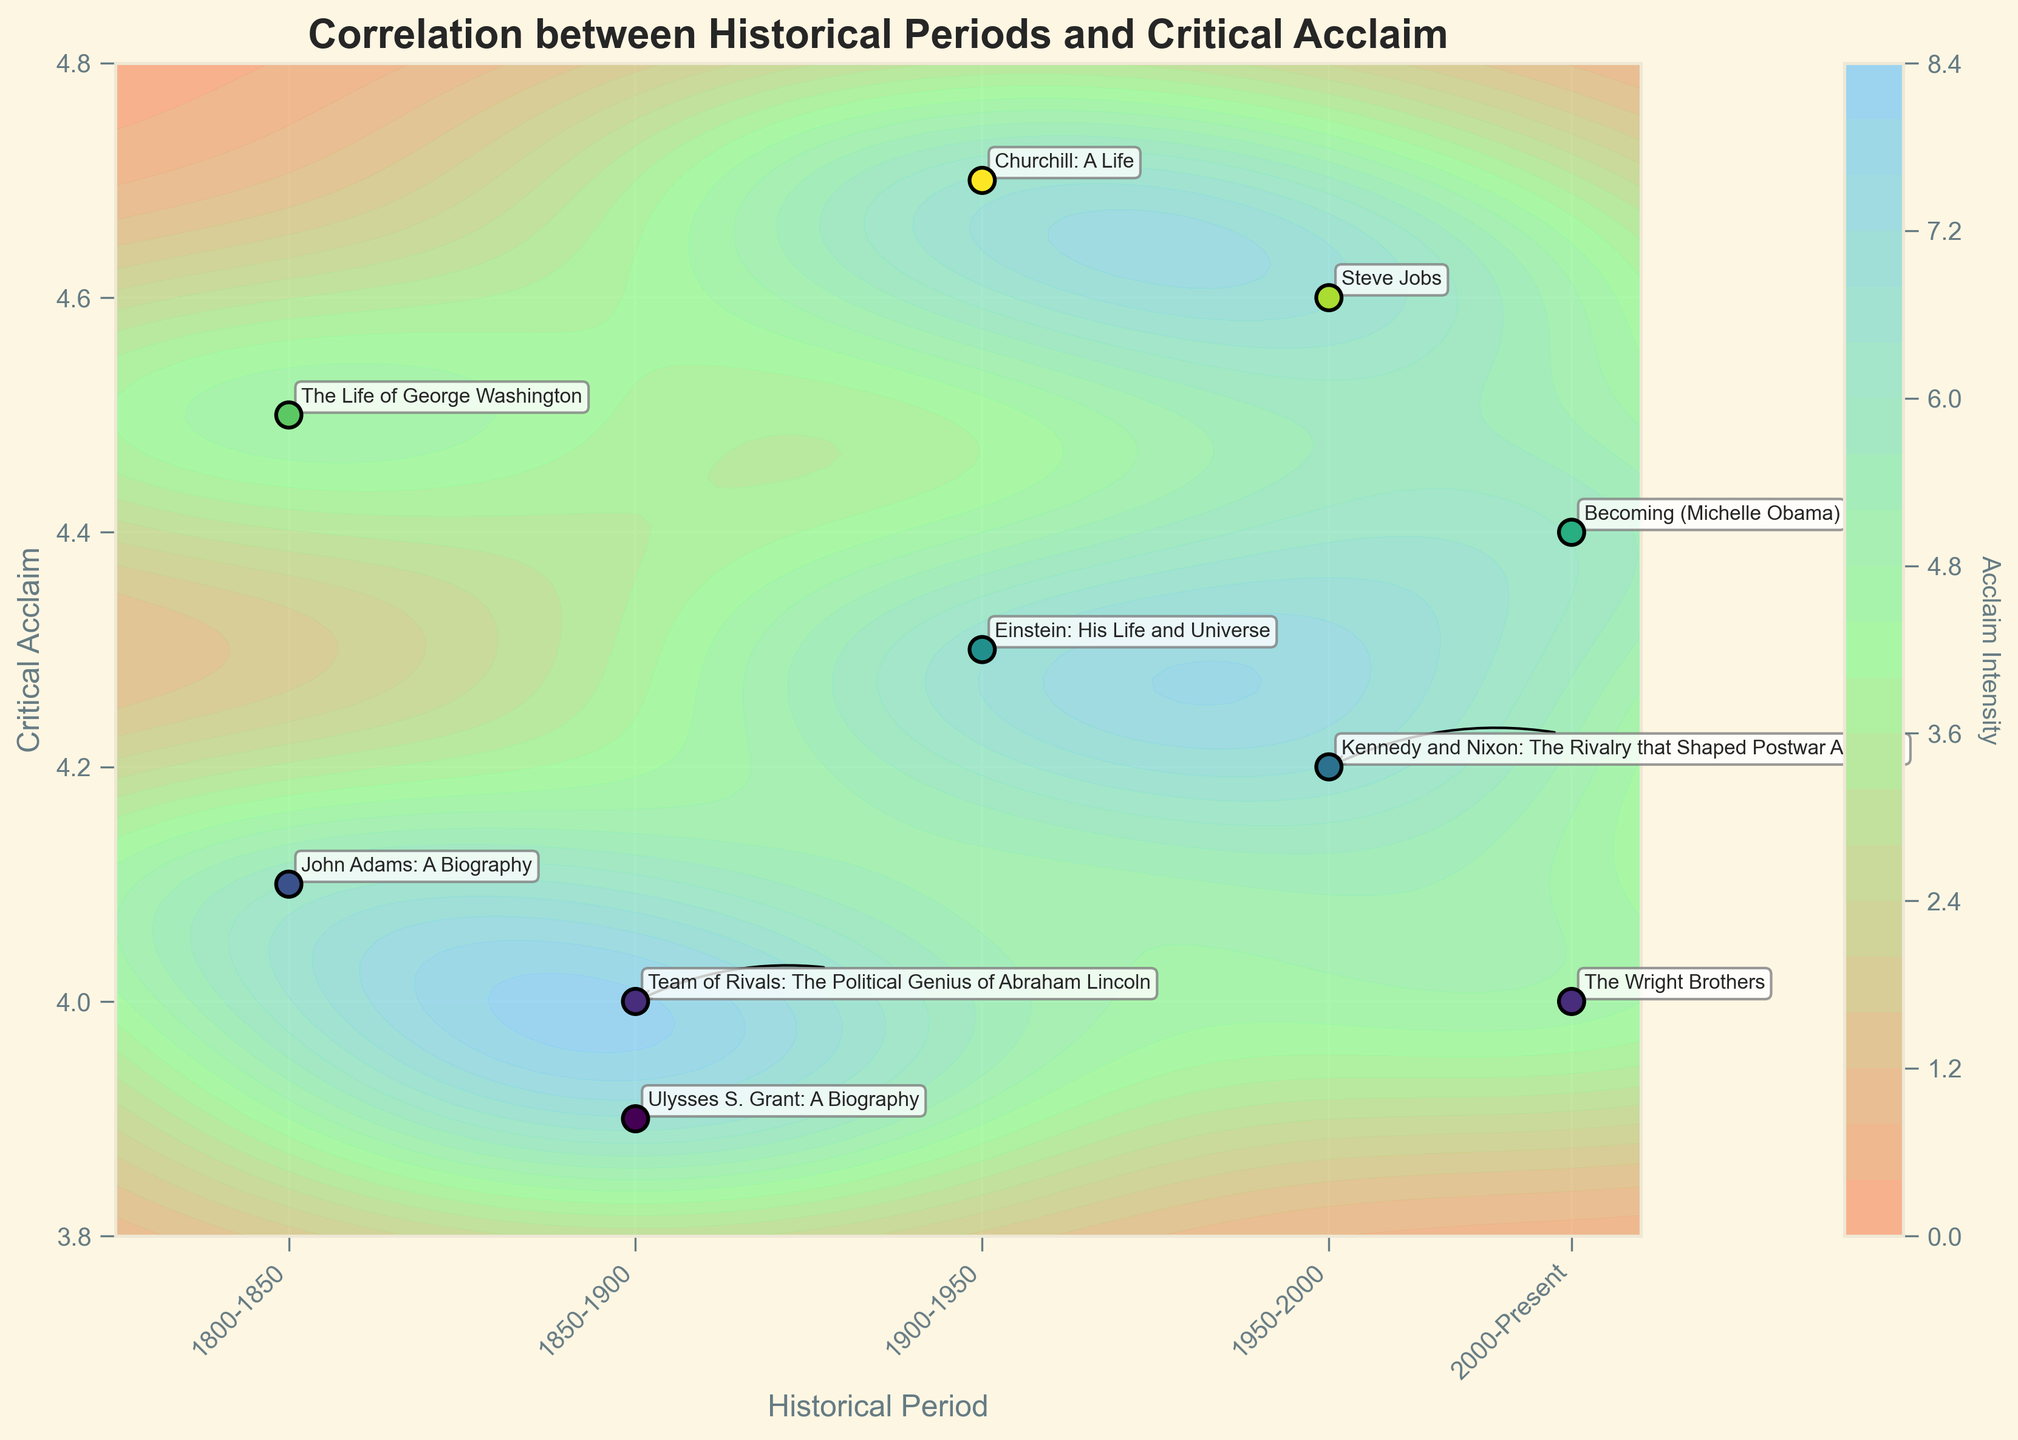What is the title of the plot? The title of the plot is prominently displayed at the top of the figure. It states "Correlation between Historical Periods and Critical Acclaim", which informs viewers about the main focus of the graph.
Answer: Correlation between Historical Periods and Critical Acclaim How many data points are shown in the scatter plot? By counting all the labeled points on the scatter plot, it is evident that there are labels for 10 different biographies, indicating 10 data points.
Answer: 10 Which historical period has the highest critical acclaim according to the data points? The period 1900-1950 shows two high critical acclaim values of 4.7 and 4.3, the highest among other periods according to the scatter points.
Answer: 1900-1950 How many historical periods are represented in the plot? Historical periods are represented along the x-axis, and by checking the tick labels, we can count that there are five distinct periods: 1800-1850, 1850-1900, 1900-1950, 1950-2000, and 2000-Present.
Answer: 5 Which biography received the highest critical acclaim, and what period was it from? By observing the scatter plot, the biography "Churchill: A Life" has the highest critical acclaim value of 4.7, and it falls in the 1900-1950 period.
Answer: Churchill: A Life, 1900-1950 Compare the critical acclaim of the biographies "The Life of George Washington" and "Becoming (Michelle Obama)." Which one was higher? "The Life of George Washington" has a critical acclaim of 4.5, while "Becoming (Michelle Obama)" has 4.4. By comparing these values, we see that the former is higher.
Answer: The Life of George Washington Which biography from the 1950-2000 period has the lower critical acclaim? To find this, we look at the scatter points in the 1950-2000 period on the x-axis and compare their critical acclaim values. "Steve Jobs" has 4.6 and "Kennedy and Nixon: The Rivalry that Shaped Postwar America" has 4.2; thus, the latter is lower.
Answer: Kennedy and Nixon: The Rivalry that Shaped Postwar America What is the general trend of critical acclaim through historical periods? Observing the contour plot and scatter points, the critical acclaim remains relatively high across all periods with some scatter around the middle range (4.0 - 4.7). There doesn’t appear to be a strong downward or upward trend.
Answer: Relatively stable with slight variations What does the color gradient in the contour plot represent? The contour plot uses a gradient colormap that ranges from lighter colors to darker colors indicating different intensities of critical acclaim. The color typically shows regions of higher acclaim intensity more prominently.
Answer: Acclaim intensity How many data points show critical acclaim above 4.5? By checking the scatter points, we identify that "Churchill: A Life," "Steve Jobs," and "The Life of George Washington" all have acclaim values higher than 4.5. That's three data points.
Answer: 3 